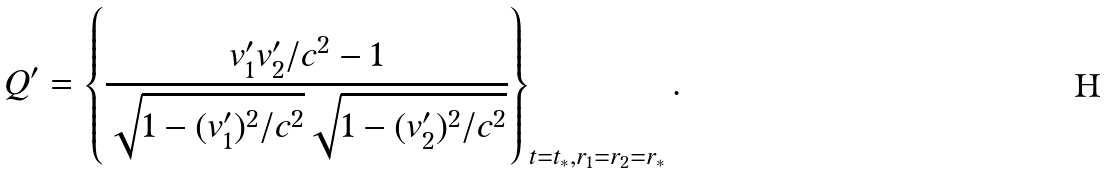Convert formula to latex. <formula><loc_0><loc_0><loc_500><loc_500>Q ^ { \prime } = \left \{ \frac { v _ { 1 } ^ { \prime } v _ { 2 } ^ { \prime } / c ^ { 2 } - 1 } { \sqrt { 1 - ( v _ { 1 } ^ { \prime } ) ^ { 2 } / c ^ { 2 } } \sqrt { 1 - ( v _ { 2 } ^ { \prime } ) ^ { 2 } / c ^ { 2 } } } \right \} _ { t = t _ { * } , r _ { 1 } = r _ { 2 } = r _ { * } } .</formula> 